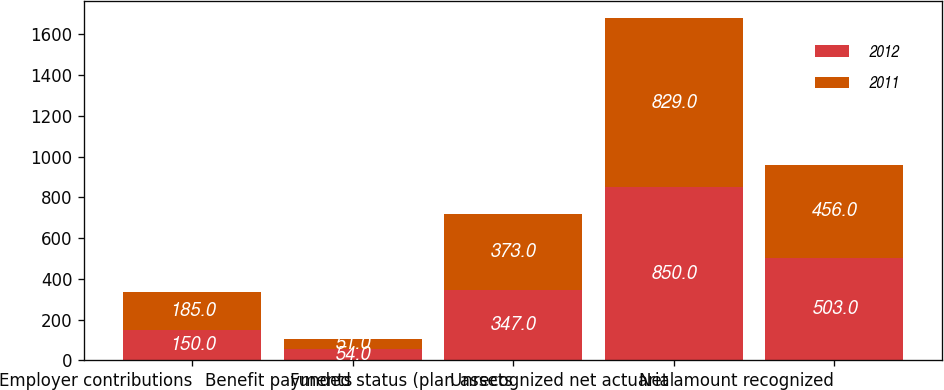<chart> <loc_0><loc_0><loc_500><loc_500><stacked_bar_chart><ecel><fcel>Employer contributions<fcel>Benefit payments<fcel>Funded status (plan assets<fcel>Unrecognized net actuarial<fcel>Net amount recognized<nl><fcel>2012<fcel>150<fcel>54<fcel>347<fcel>850<fcel>503<nl><fcel>2011<fcel>185<fcel>51<fcel>373<fcel>829<fcel>456<nl></chart> 